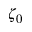Convert formula to latex. <formula><loc_0><loc_0><loc_500><loc_500>\zeta _ { 0 }</formula> 